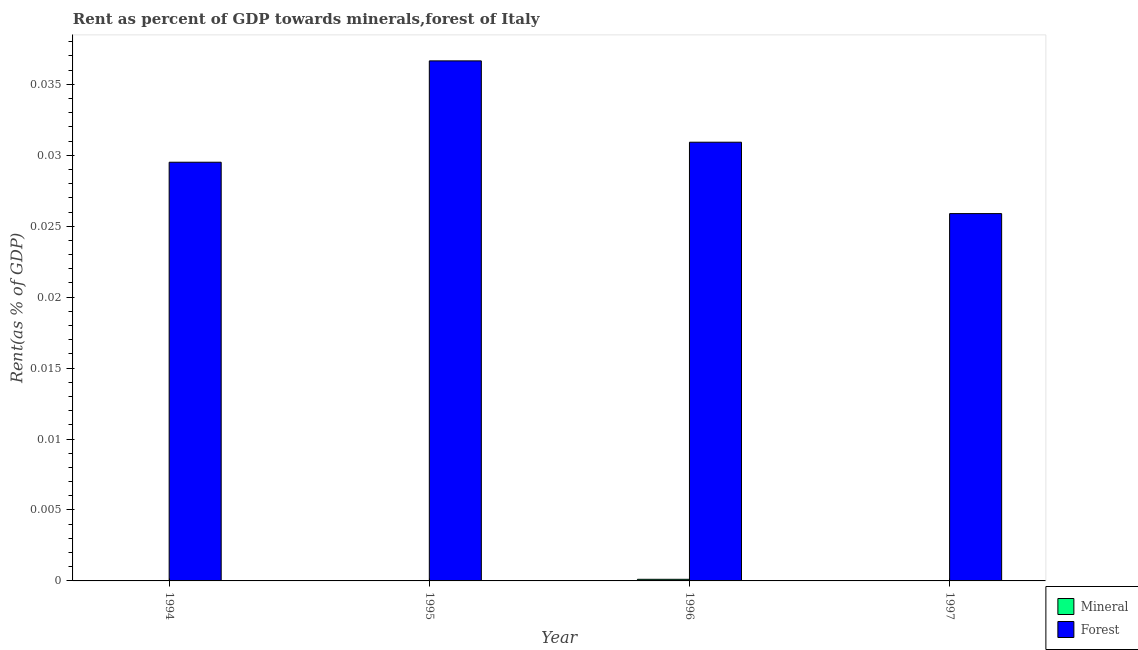How many groups of bars are there?
Give a very brief answer. 4. How many bars are there on the 2nd tick from the left?
Make the answer very short. 2. How many bars are there on the 2nd tick from the right?
Offer a terse response. 2. What is the label of the 2nd group of bars from the left?
Offer a terse response. 1995. What is the mineral rent in 1997?
Provide a short and direct response. 1.39725048171068e-5. Across all years, what is the maximum mineral rent?
Offer a very short reply. 0. Across all years, what is the minimum mineral rent?
Offer a very short reply. 2.63475280752161e-6. What is the total mineral rent in the graph?
Give a very brief answer. 0. What is the difference between the forest rent in 1995 and that in 1997?
Your answer should be compact. 0.01. What is the difference between the mineral rent in 1997 and the forest rent in 1994?
Your answer should be compact. -9.829404343980799e-6. What is the average mineral rent per year?
Provide a short and direct response. 3.865203848071e-5. What is the ratio of the mineral rent in 1994 to that in 1996?
Offer a very short reply. 0.21. Is the mineral rent in 1995 less than that in 1997?
Your answer should be compact. Yes. What is the difference between the highest and the second highest forest rent?
Provide a short and direct response. 0.01. What is the difference between the highest and the lowest forest rent?
Your answer should be compact. 0.01. Is the sum of the mineral rent in 1994 and 1996 greater than the maximum forest rent across all years?
Your answer should be compact. Yes. What does the 2nd bar from the left in 1994 represents?
Keep it short and to the point. Forest. What does the 2nd bar from the right in 1994 represents?
Ensure brevity in your answer.  Mineral. How many years are there in the graph?
Offer a terse response. 4. What is the difference between two consecutive major ticks on the Y-axis?
Ensure brevity in your answer.  0.01. Are the values on the major ticks of Y-axis written in scientific E-notation?
Keep it short and to the point. No. Does the graph contain any zero values?
Make the answer very short. No. Does the graph contain grids?
Offer a terse response. No. Where does the legend appear in the graph?
Offer a very short reply. Bottom right. How many legend labels are there?
Give a very brief answer. 2. How are the legend labels stacked?
Provide a short and direct response. Vertical. What is the title of the graph?
Ensure brevity in your answer.  Rent as percent of GDP towards minerals,forest of Italy. Does "Techinal cooperation" appear as one of the legend labels in the graph?
Give a very brief answer. No. What is the label or title of the Y-axis?
Offer a very short reply. Rent(as % of GDP). What is the Rent(as % of GDP) in Mineral in 1994?
Provide a succinct answer. 2.38019091610876e-5. What is the Rent(as % of GDP) of Forest in 1994?
Your answer should be compact. 0.03. What is the Rent(as % of GDP) of Mineral in 1995?
Offer a very short reply. 2.63475280752161e-6. What is the Rent(as % of GDP) of Forest in 1995?
Provide a short and direct response. 0.04. What is the Rent(as % of GDP) in Mineral in 1996?
Offer a very short reply. 0. What is the Rent(as % of GDP) in Forest in 1996?
Provide a short and direct response. 0.03. What is the Rent(as % of GDP) in Mineral in 1997?
Your answer should be very brief. 1.39725048171068e-5. What is the Rent(as % of GDP) in Forest in 1997?
Ensure brevity in your answer.  0.03. Across all years, what is the maximum Rent(as % of GDP) of Mineral?
Offer a terse response. 0. Across all years, what is the maximum Rent(as % of GDP) of Forest?
Your answer should be very brief. 0.04. Across all years, what is the minimum Rent(as % of GDP) of Mineral?
Ensure brevity in your answer.  2.63475280752161e-6. Across all years, what is the minimum Rent(as % of GDP) in Forest?
Provide a short and direct response. 0.03. What is the total Rent(as % of GDP) in Mineral in the graph?
Your answer should be compact. 0. What is the total Rent(as % of GDP) of Forest in the graph?
Your answer should be very brief. 0.12. What is the difference between the Rent(as % of GDP) in Mineral in 1994 and that in 1995?
Make the answer very short. 0. What is the difference between the Rent(as % of GDP) of Forest in 1994 and that in 1995?
Your answer should be very brief. -0.01. What is the difference between the Rent(as % of GDP) in Mineral in 1994 and that in 1996?
Provide a short and direct response. -0. What is the difference between the Rent(as % of GDP) of Forest in 1994 and that in 1996?
Provide a succinct answer. -0. What is the difference between the Rent(as % of GDP) of Mineral in 1994 and that in 1997?
Your response must be concise. 0. What is the difference between the Rent(as % of GDP) in Forest in 1994 and that in 1997?
Ensure brevity in your answer.  0. What is the difference between the Rent(as % of GDP) of Mineral in 1995 and that in 1996?
Your answer should be compact. -0. What is the difference between the Rent(as % of GDP) of Forest in 1995 and that in 1996?
Give a very brief answer. 0.01. What is the difference between the Rent(as % of GDP) of Mineral in 1995 and that in 1997?
Provide a short and direct response. -0. What is the difference between the Rent(as % of GDP) in Forest in 1995 and that in 1997?
Give a very brief answer. 0.01. What is the difference between the Rent(as % of GDP) in Mineral in 1996 and that in 1997?
Offer a very short reply. 0. What is the difference between the Rent(as % of GDP) in Forest in 1996 and that in 1997?
Offer a very short reply. 0.01. What is the difference between the Rent(as % of GDP) of Mineral in 1994 and the Rent(as % of GDP) of Forest in 1995?
Provide a short and direct response. -0.04. What is the difference between the Rent(as % of GDP) of Mineral in 1994 and the Rent(as % of GDP) of Forest in 1996?
Your answer should be compact. -0.03. What is the difference between the Rent(as % of GDP) of Mineral in 1994 and the Rent(as % of GDP) of Forest in 1997?
Offer a terse response. -0.03. What is the difference between the Rent(as % of GDP) of Mineral in 1995 and the Rent(as % of GDP) of Forest in 1996?
Offer a terse response. -0.03. What is the difference between the Rent(as % of GDP) in Mineral in 1995 and the Rent(as % of GDP) in Forest in 1997?
Offer a very short reply. -0.03. What is the difference between the Rent(as % of GDP) in Mineral in 1996 and the Rent(as % of GDP) in Forest in 1997?
Offer a very short reply. -0.03. What is the average Rent(as % of GDP) of Mineral per year?
Your answer should be very brief. 0. What is the average Rent(as % of GDP) in Forest per year?
Offer a very short reply. 0.03. In the year 1994, what is the difference between the Rent(as % of GDP) of Mineral and Rent(as % of GDP) of Forest?
Offer a terse response. -0.03. In the year 1995, what is the difference between the Rent(as % of GDP) in Mineral and Rent(as % of GDP) in Forest?
Your answer should be very brief. -0.04. In the year 1996, what is the difference between the Rent(as % of GDP) of Mineral and Rent(as % of GDP) of Forest?
Provide a succinct answer. -0.03. In the year 1997, what is the difference between the Rent(as % of GDP) in Mineral and Rent(as % of GDP) in Forest?
Ensure brevity in your answer.  -0.03. What is the ratio of the Rent(as % of GDP) of Mineral in 1994 to that in 1995?
Keep it short and to the point. 9.03. What is the ratio of the Rent(as % of GDP) in Forest in 1994 to that in 1995?
Make the answer very short. 0.81. What is the ratio of the Rent(as % of GDP) in Mineral in 1994 to that in 1996?
Ensure brevity in your answer.  0.21. What is the ratio of the Rent(as % of GDP) of Forest in 1994 to that in 1996?
Your answer should be compact. 0.95. What is the ratio of the Rent(as % of GDP) of Mineral in 1994 to that in 1997?
Give a very brief answer. 1.7. What is the ratio of the Rent(as % of GDP) of Forest in 1994 to that in 1997?
Your answer should be compact. 1.14. What is the ratio of the Rent(as % of GDP) of Mineral in 1995 to that in 1996?
Your answer should be compact. 0.02. What is the ratio of the Rent(as % of GDP) in Forest in 1995 to that in 1996?
Ensure brevity in your answer.  1.19. What is the ratio of the Rent(as % of GDP) in Mineral in 1995 to that in 1997?
Offer a terse response. 0.19. What is the ratio of the Rent(as % of GDP) of Forest in 1995 to that in 1997?
Your response must be concise. 1.42. What is the ratio of the Rent(as % of GDP) in Mineral in 1996 to that in 1997?
Your answer should be compact. 8.17. What is the ratio of the Rent(as % of GDP) in Forest in 1996 to that in 1997?
Ensure brevity in your answer.  1.19. What is the difference between the highest and the second highest Rent(as % of GDP) of Forest?
Keep it short and to the point. 0.01. What is the difference between the highest and the lowest Rent(as % of GDP) of Mineral?
Give a very brief answer. 0. What is the difference between the highest and the lowest Rent(as % of GDP) in Forest?
Offer a terse response. 0.01. 